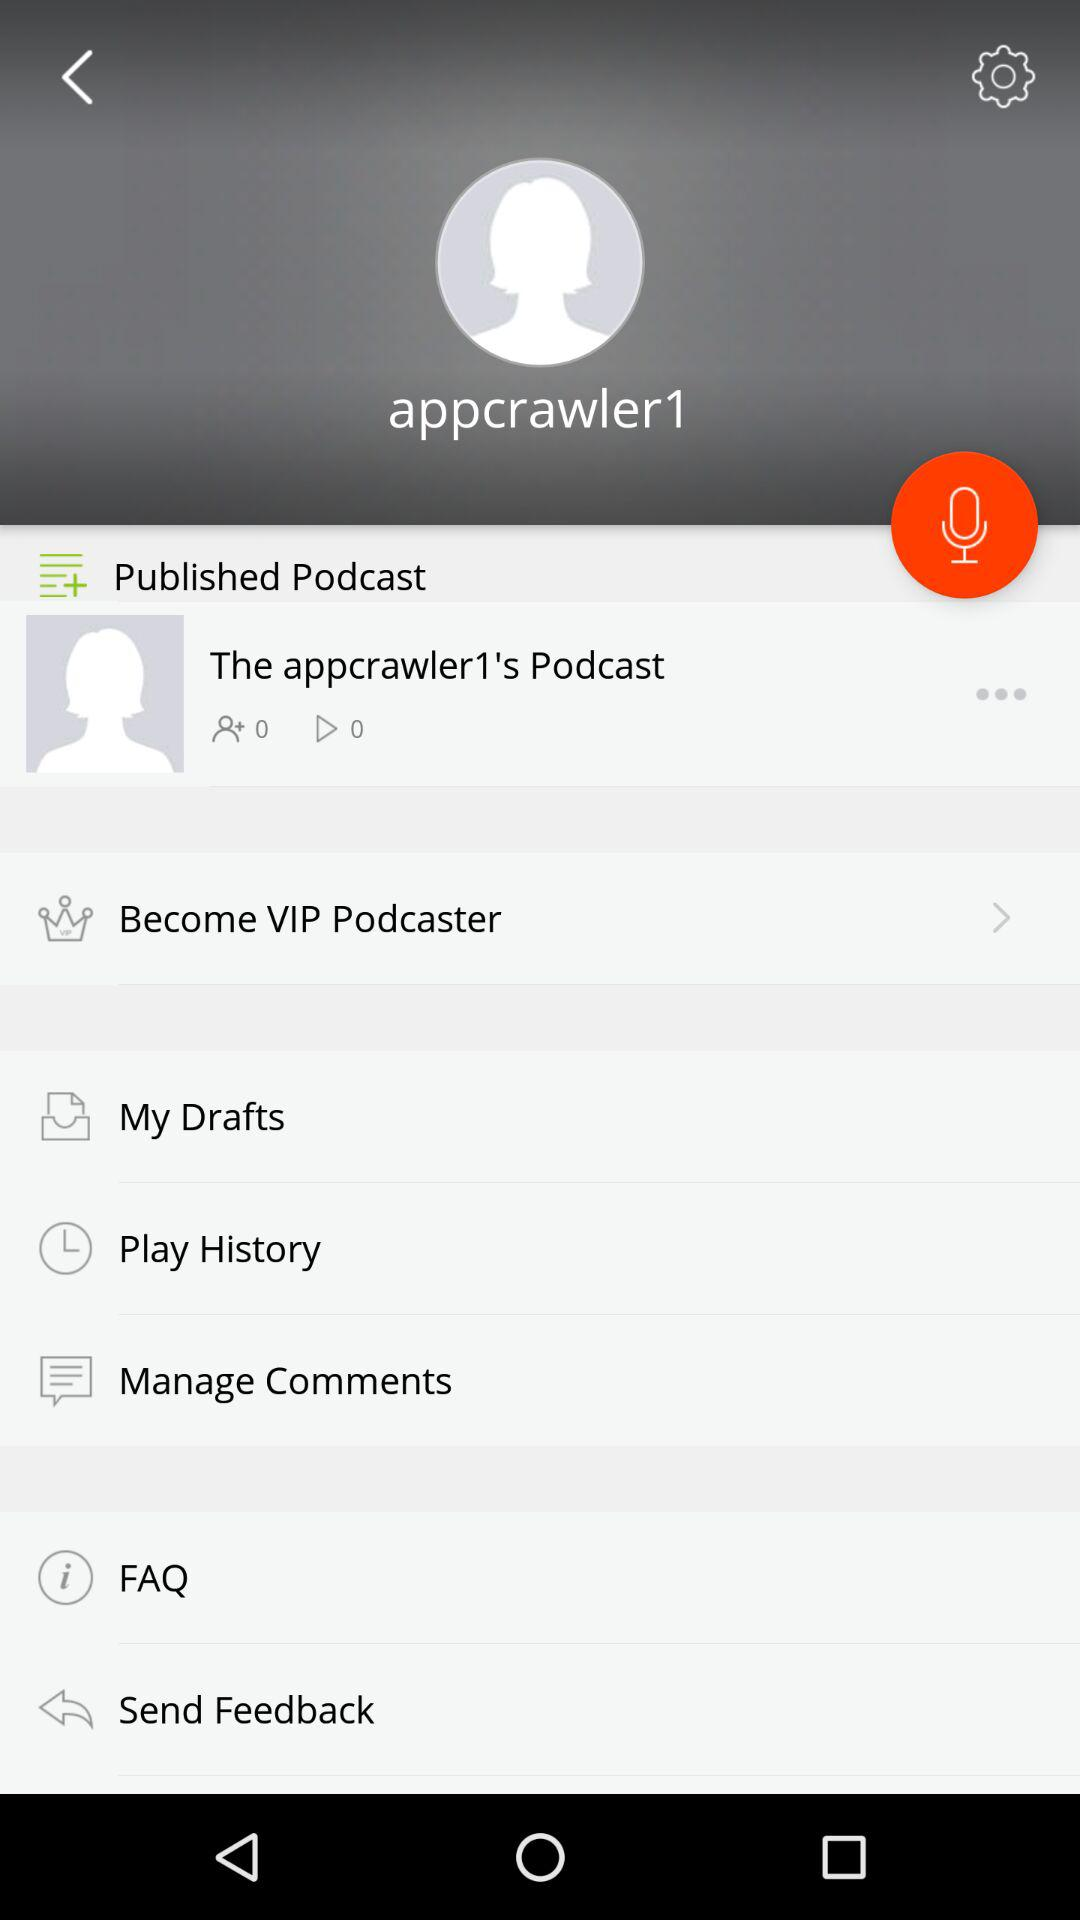How many podcasts are there in total?
When the provided information is insufficient, respond with <no answer>. <no answer> 